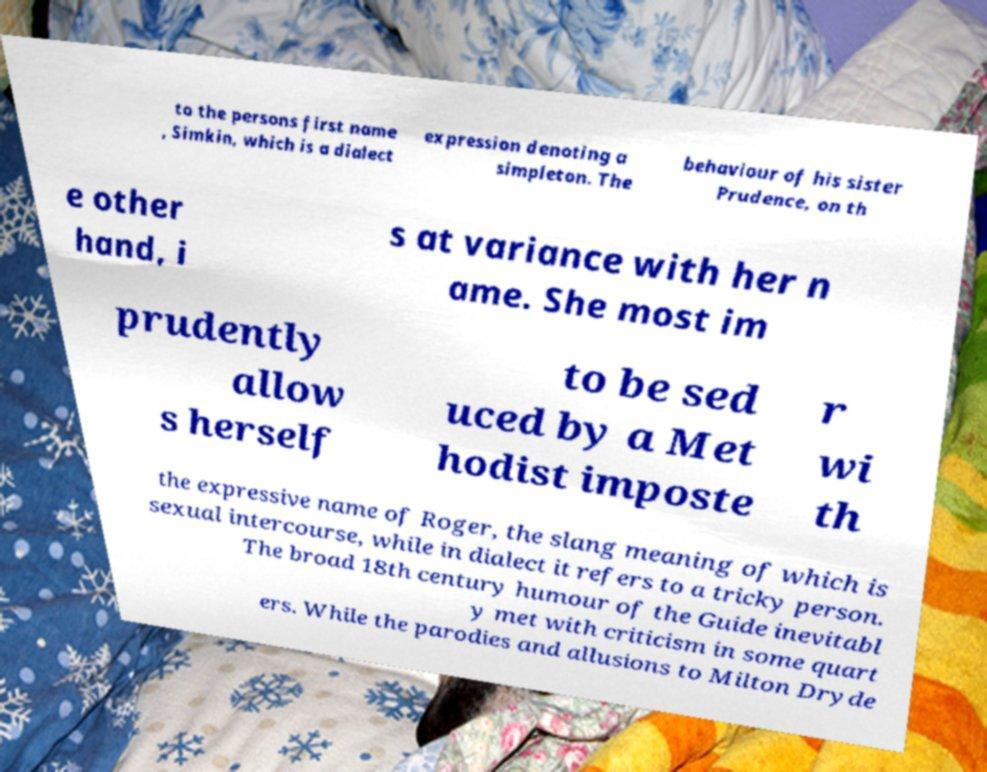For documentation purposes, I need the text within this image transcribed. Could you provide that? to the persons first name , Simkin, which is a dialect expression denoting a simpleton. The behaviour of his sister Prudence, on th e other hand, i s at variance with her n ame. She most im prudently allow s herself to be sed uced by a Met hodist imposte r wi th the expressive name of Roger, the slang meaning of which is sexual intercourse, while in dialect it refers to a tricky person. The broad 18th century humour of the Guide inevitabl y met with criticism in some quart ers. While the parodies and allusions to Milton Dryde 